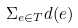<formula> <loc_0><loc_0><loc_500><loc_500>\Sigma _ { e \in T } d ( e )</formula> 